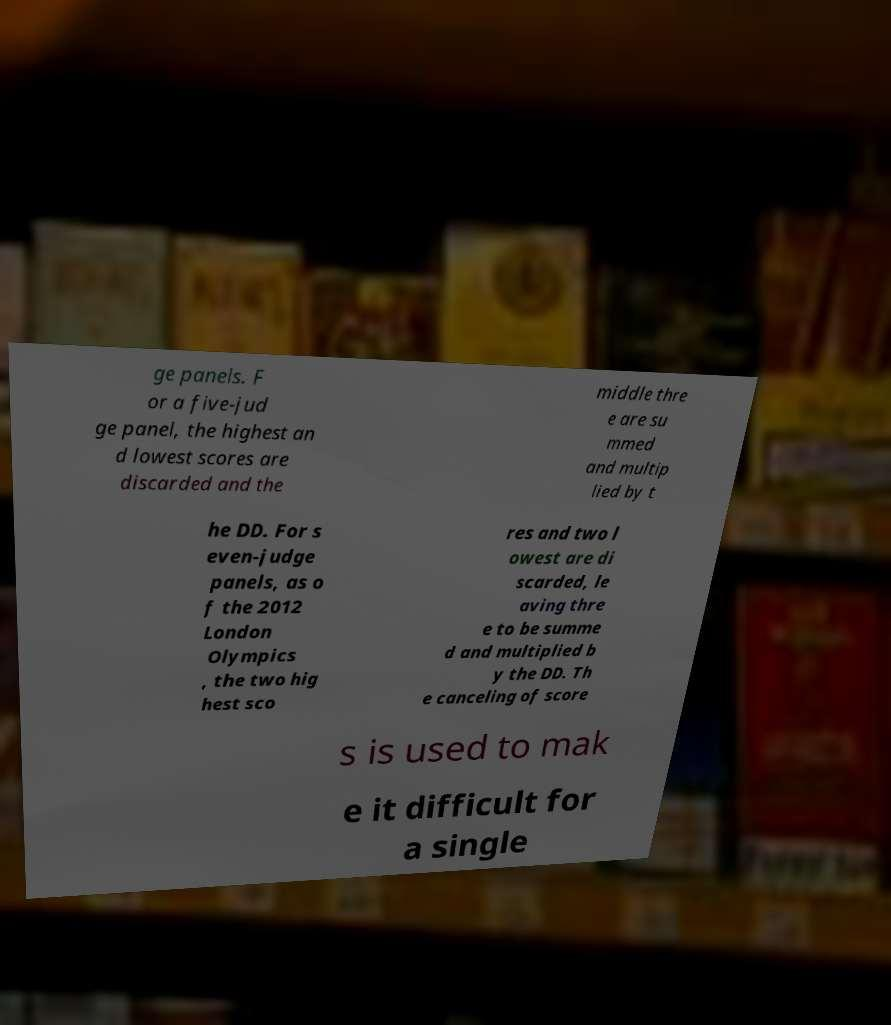Can you accurately transcribe the text from the provided image for me? ge panels. F or a five-jud ge panel, the highest an d lowest scores are discarded and the middle thre e are su mmed and multip lied by t he DD. For s even-judge panels, as o f the 2012 London Olympics , the two hig hest sco res and two l owest are di scarded, le aving thre e to be summe d and multiplied b y the DD. Th e canceling of score s is used to mak e it difficult for a single 